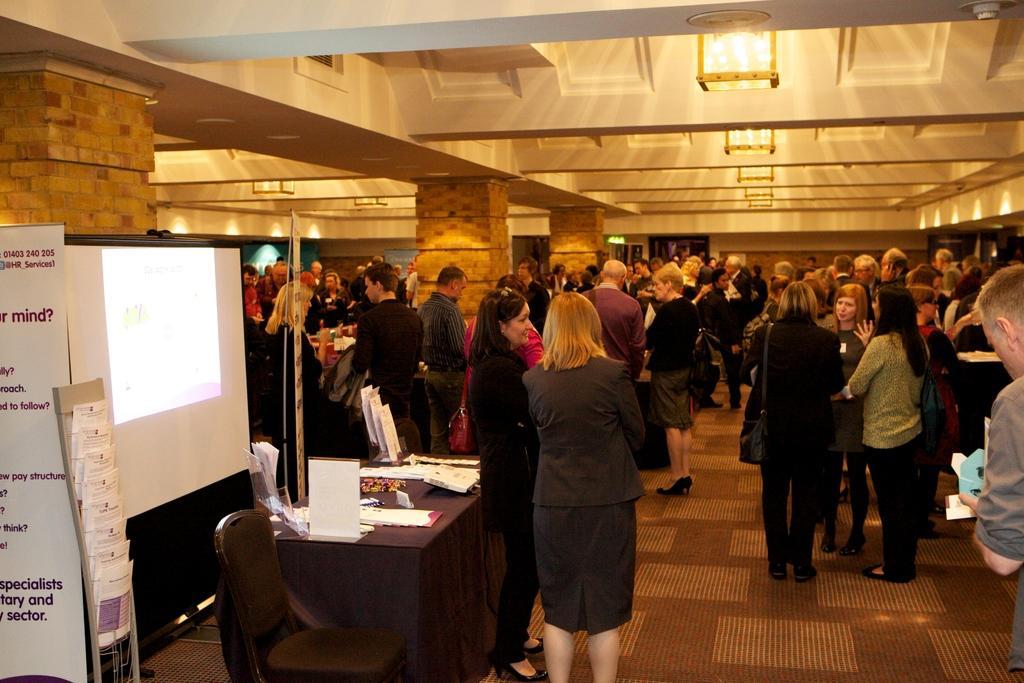Can you describe this image briefly? In this image we can see group of people standing on the floor. Here we can see a table, chair, cloth, posters, screen, papers, pillars, lights, and ceiling. 